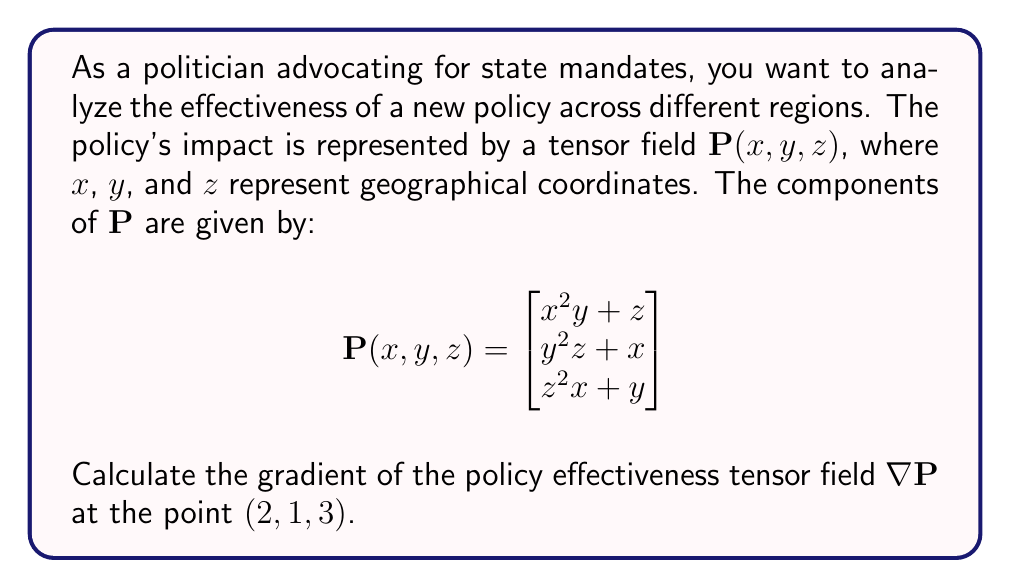Can you answer this question? To solve this problem, we need to follow these steps:

1) The gradient of a tensor field is defined as:

   $$\nabla \mathbf{P} = \begin{bmatrix}
   \frac{\partial P_1}{\partial x} & \frac{\partial P_1}{\partial y} & \frac{\partial P_1}{\partial z} \\
   \frac{\partial P_2}{\partial x} & \frac{\partial P_2}{\partial y} & \frac{\partial P_2}{\partial z} \\
   \frac{\partial P_3}{\partial x} & \frac{\partial P_3}{\partial y} & \frac{\partial P_3}{\partial z}
   \end{bmatrix}$$

2) Let's calculate each partial derivative:

   $\frac{\partial P_1}{\partial x} = 2xy$
   $\frac{\partial P_1}{\partial y} = x^2$
   $\frac{\partial P_1}{\partial z} = 1$

   $\frac{\partial P_2}{\partial x} = 1$
   $\frac{\partial P_2}{\partial y} = 2yz$
   $\frac{\partial P_2}{\partial z} = y^2$

   $\frac{\partial P_3}{\partial x} = z^2$
   $\frac{\partial P_3}{\partial y} = 1$
   $\frac{\partial P_3}{\partial z} = 2zx$

3) Now, we can form the gradient tensor:

   $$\nabla \mathbf{P} = \begin{bmatrix}
   2xy & x^2 & 1 \\
   1 & 2yz & y^2 \\
   z^2 & 1 & 2zx
   \end{bmatrix}$$

4) Evaluate this at the point $(2, 1, 3)$:

   $$\nabla \mathbf{P}(2,1,3) = \begin{bmatrix}
   2(2)(1) & 2^2 & 1 \\
   1 & 2(1)(3) & 1^2 \\
   3^2 & 1 & 2(3)(2)
   \end{bmatrix}$$

5) Simplify:

   $$\nabla \mathbf{P}(2,1,3) = \begin{bmatrix}
   4 & 4 & 1 \\
   1 & 6 & 1 \\
   9 & 1 & 12
   \end{bmatrix}$$

This gradient tensor represents the rate of change of the policy effectiveness in different directions at the given point.
Answer: $$\nabla \mathbf{P}(2,1,3) = \begin{bmatrix}
4 & 4 & 1 \\
1 & 6 & 1 \\
9 & 1 & 12
\end{bmatrix}$$ 